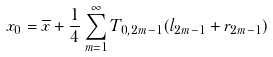<formula> <loc_0><loc_0><loc_500><loc_500>x _ { 0 } = \overline { x } + \frac { 1 } { 4 } \sum _ { m = 1 } ^ { \infty } T _ { 0 , 2 m - 1 } ( l _ { 2 m - 1 } + r _ { 2 m - 1 } )</formula> 